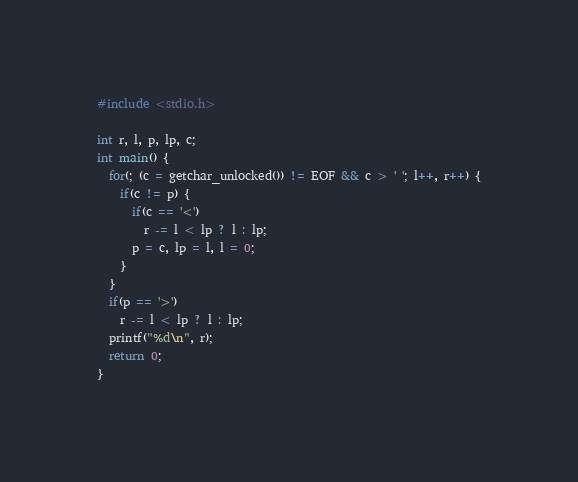<code> <loc_0><loc_0><loc_500><loc_500><_C_>#include <stdio.h>

int r, l, p, lp, c;
int main() {
  for(; (c = getchar_unlocked()) != EOF && c > ' '; l++, r++) {
    if(c != p) { 
      if(c == '<')
        r -= l < lp ? l : lp;
      p = c, lp = l, l = 0;
    }
  }
  if(p == '>')
    r -= l < lp ? l : lp;
  printf("%d\n", r);
  return 0;
}
</code> 